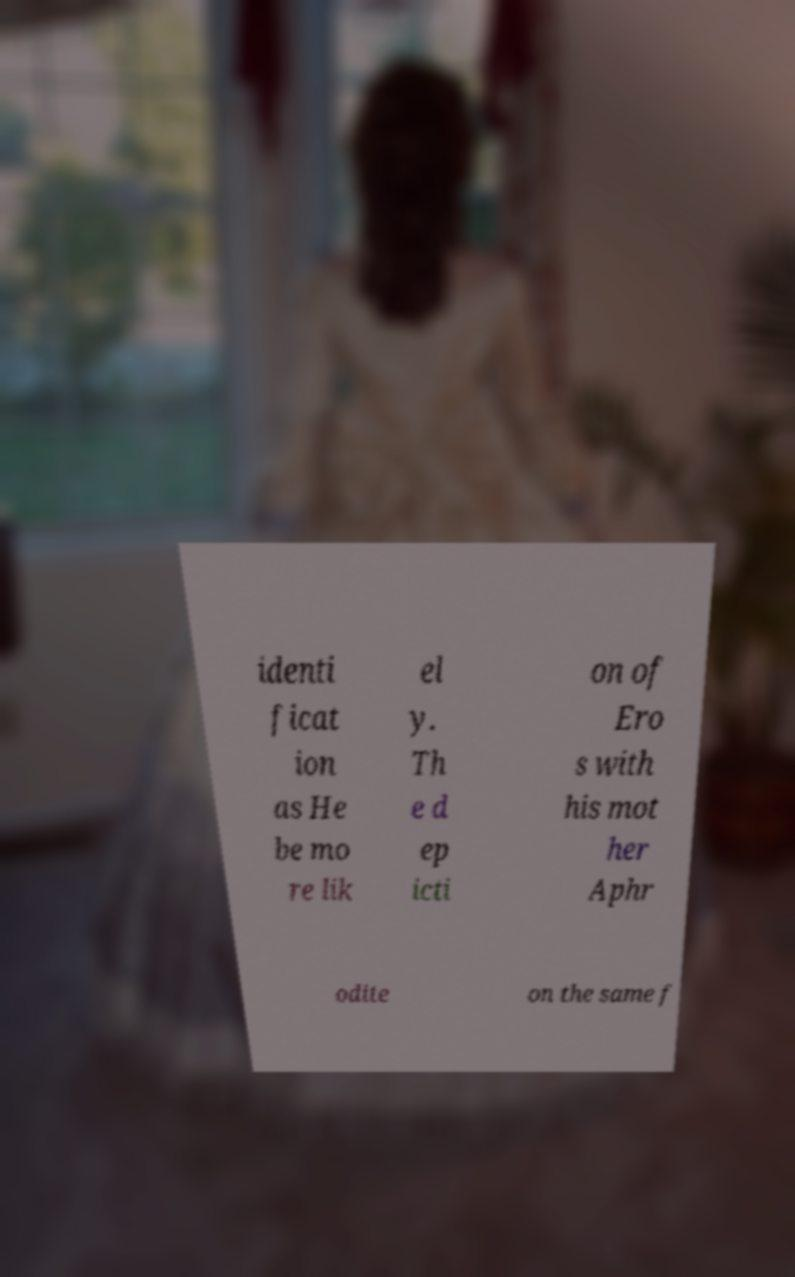I need the written content from this picture converted into text. Can you do that? identi ficat ion as He be mo re lik el y. Th e d ep icti on of Ero s with his mot her Aphr odite on the same f 